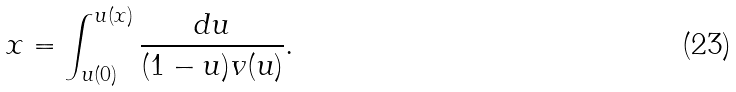<formula> <loc_0><loc_0><loc_500><loc_500>x = \int _ { u ( 0 ) } ^ { u ( x ) } \frac { d u } { ( 1 - u ) v ( u ) } .</formula> 